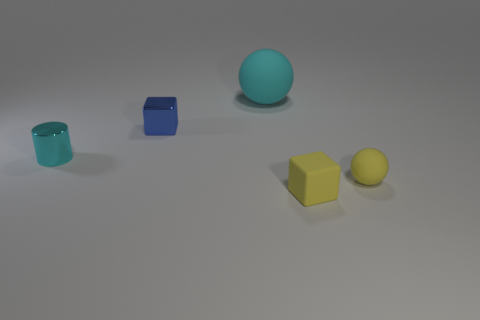Is the material of the big sphere the same as the cylinder?
Your response must be concise. No. Is the cylinder the same color as the big object?
Your response must be concise. Yes. Is the yellow cube made of the same material as the small yellow sphere right of the blue shiny block?
Your response must be concise. Yes. What number of things are blocks that are in front of the small blue thing or cyan objects that are on the right side of the small shiny cylinder?
Offer a very short reply. 2. What is the color of the tiny rubber ball?
Make the answer very short. Yellow. Are there fewer small cylinders to the right of the big matte object than large brown things?
Keep it short and to the point. No. Is there anything else that is the same shape as the cyan metal object?
Offer a terse response. No. Are any blue metal cylinders visible?
Keep it short and to the point. No. Are there fewer blue cubes than small things?
Offer a very short reply. Yes. What number of cubes have the same material as the big object?
Your answer should be very brief. 1. 